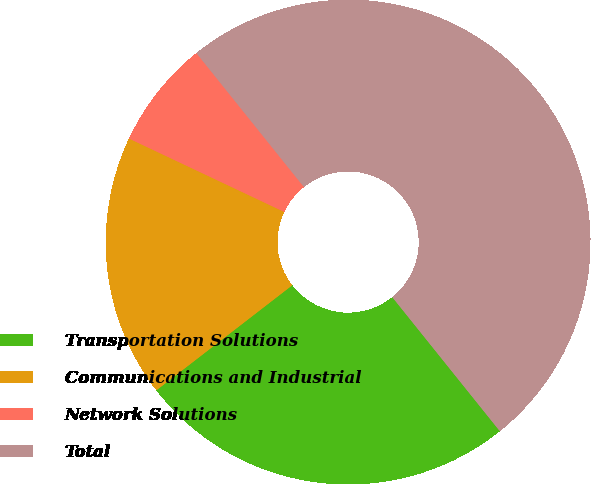<chart> <loc_0><loc_0><loc_500><loc_500><pie_chart><fcel>Transportation Solutions<fcel>Communications and Industrial<fcel>Network Solutions<fcel>Total<nl><fcel>25.29%<fcel>17.5%<fcel>7.21%<fcel>50.0%<nl></chart> 